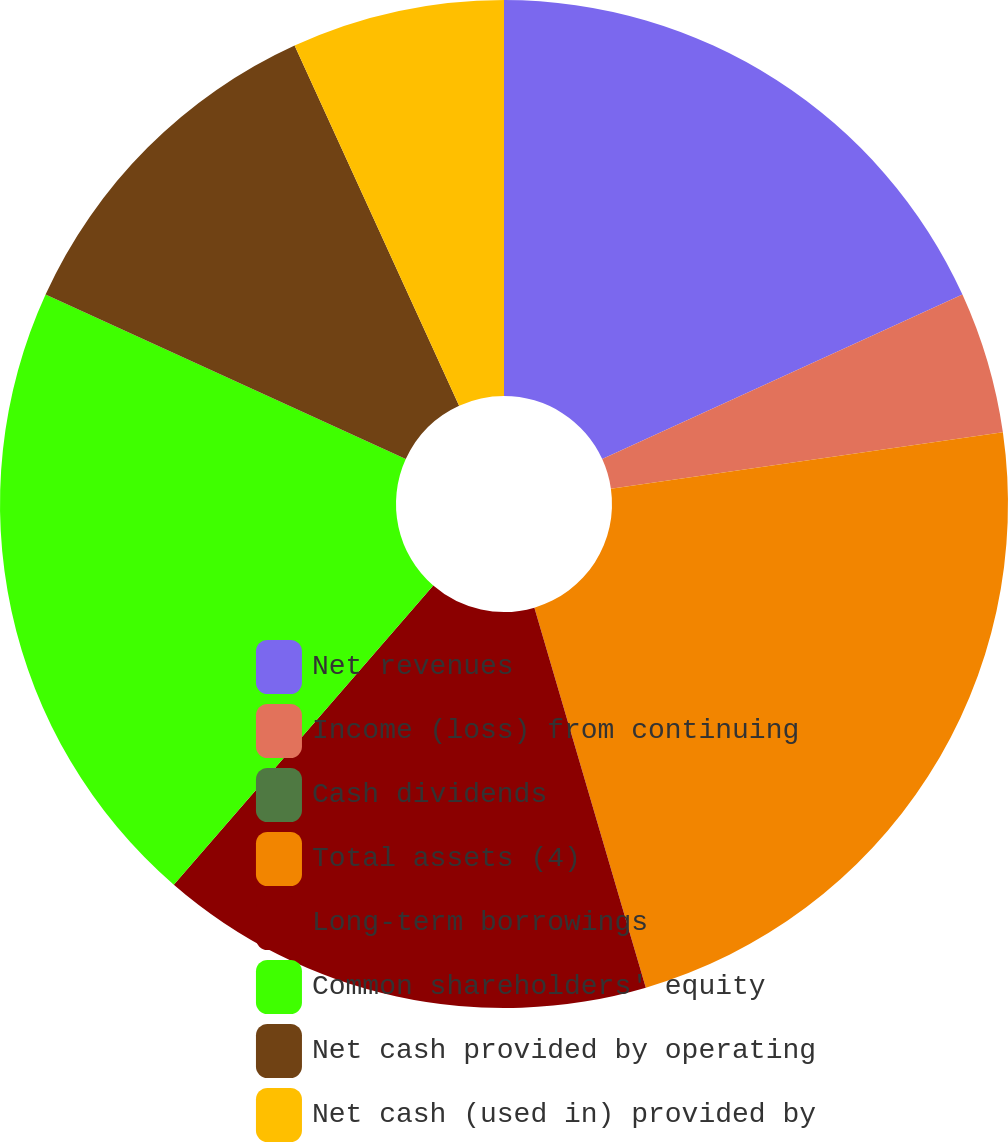Convert chart. <chart><loc_0><loc_0><loc_500><loc_500><pie_chart><fcel>Net revenues<fcel>Income (loss) from continuing<fcel>Cash dividends<fcel>Total assets (4)<fcel>Long-term borrowings<fcel>Common shareholders' equity<fcel>Net cash provided by operating<fcel>Net cash (used in) provided by<nl><fcel>18.18%<fcel>4.55%<fcel>0.0%<fcel>22.73%<fcel>15.91%<fcel>20.45%<fcel>11.36%<fcel>6.82%<nl></chart> 